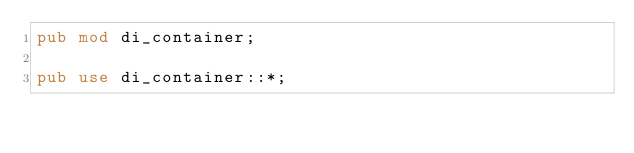Convert code to text. <code><loc_0><loc_0><loc_500><loc_500><_Rust_>pub mod di_container;

pub use di_container::*;
</code> 